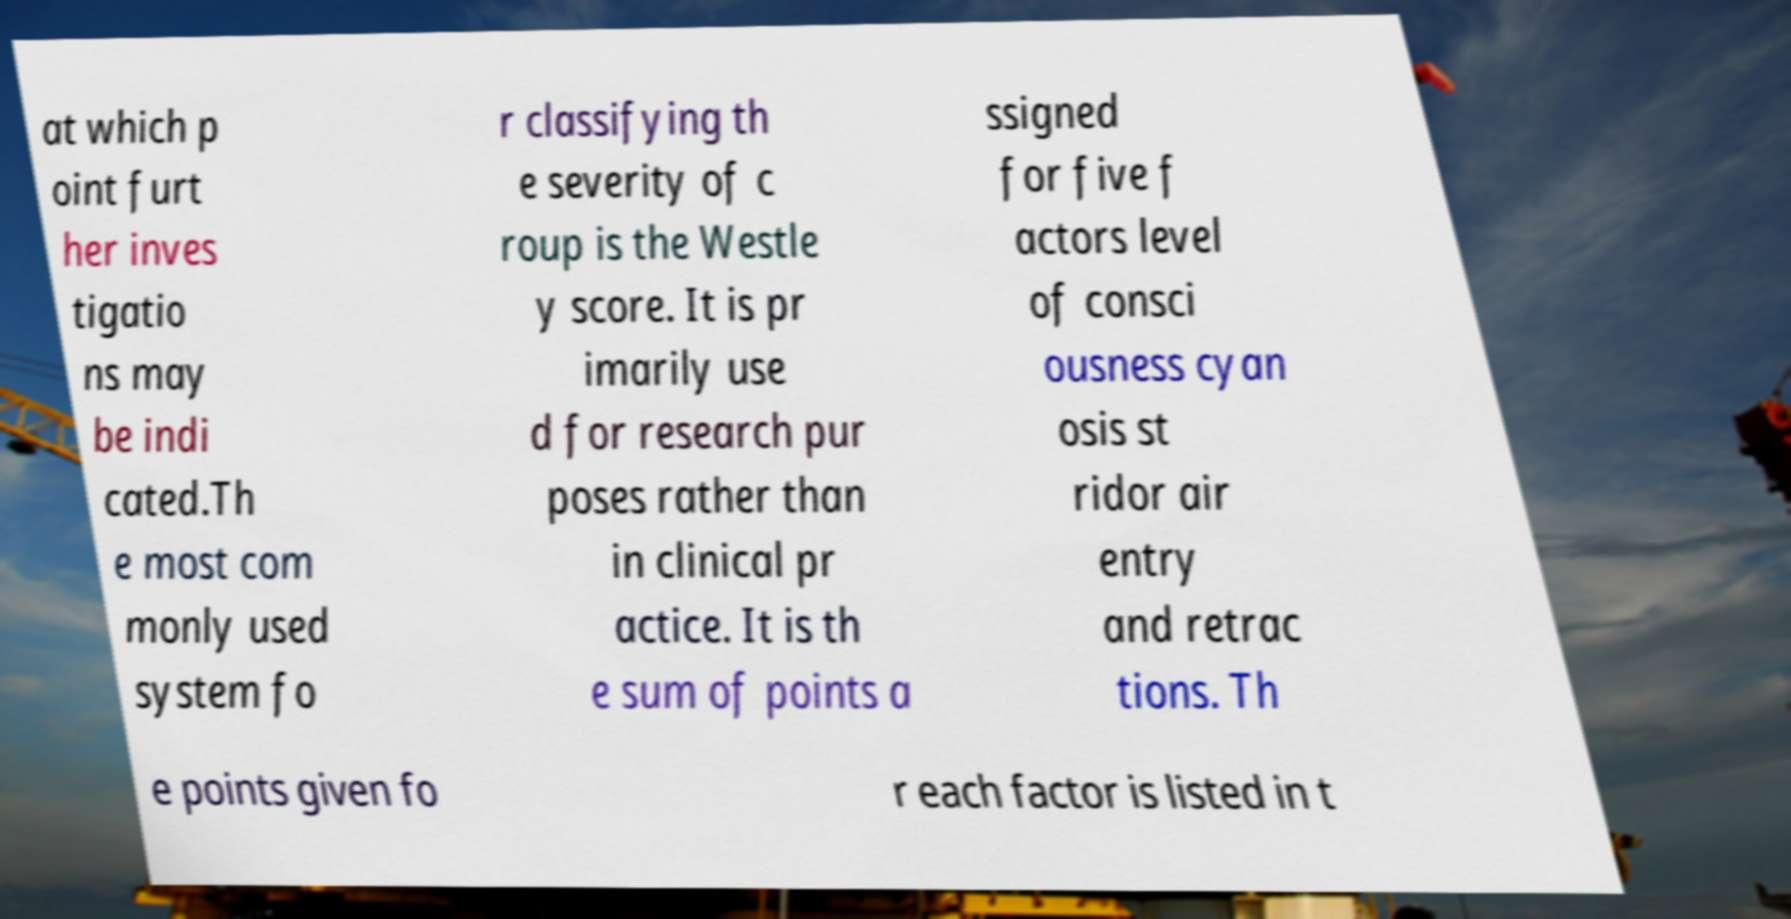Could you assist in decoding the text presented in this image and type it out clearly? at which p oint furt her inves tigatio ns may be indi cated.Th e most com monly used system fo r classifying th e severity of c roup is the Westle y score. It is pr imarily use d for research pur poses rather than in clinical pr actice. It is th e sum of points a ssigned for five f actors level of consci ousness cyan osis st ridor air entry and retrac tions. Th e points given fo r each factor is listed in t 